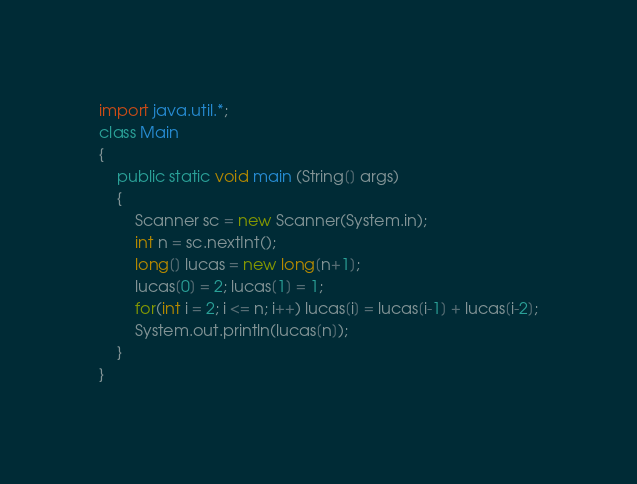<code> <loc_0><loc_0><loc_500><loc_500><_Java_>import java.util.*;
class Main
{
    public static void main (String[] args)
    {
        Scanner sc = new Scanner(System.in);
        int n = sc.nextInt();
        long[] lucas = new long[n+1];
        lucas[0] = 2; lucas[1] = 1;
        for(int i = 2; i <= n; i++) lucas[i] = lucas[i-1] + lucas[i-2];
        System.out.println(lucas[n]);
    }
}</code> 